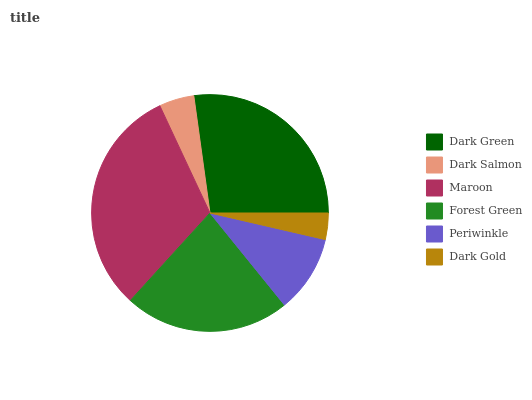Is Dark Gold the minimum?
Answer yes or no. Yes. Is Maroon the maximum?
Answer yes or no. Yes. Is Dark Salmon the minimum?
Answer yes or no. No. Is Dark Salmon the maximum?
Answer yes or no. No. Is Dark Green greater than Dark Salmon?
Answer yes or no. Yes. Is Dark Salmon less than Dark Green?
Answer yes or no. Yes. Is Dark Salmon greater than Dark Green?
Answer yes or no. No. Is Dark Green less than Dark Salmon?
Answer yes or no. No. Is Forest Green the high median?
Answer yes or no. Yes. Is Periwinkle the low median?
Answer yes or no. Yes. Is Periwinkle the high median?
Answer yes or no. No. Is Dark Salmon the low median?
Answer yes or no. No. 